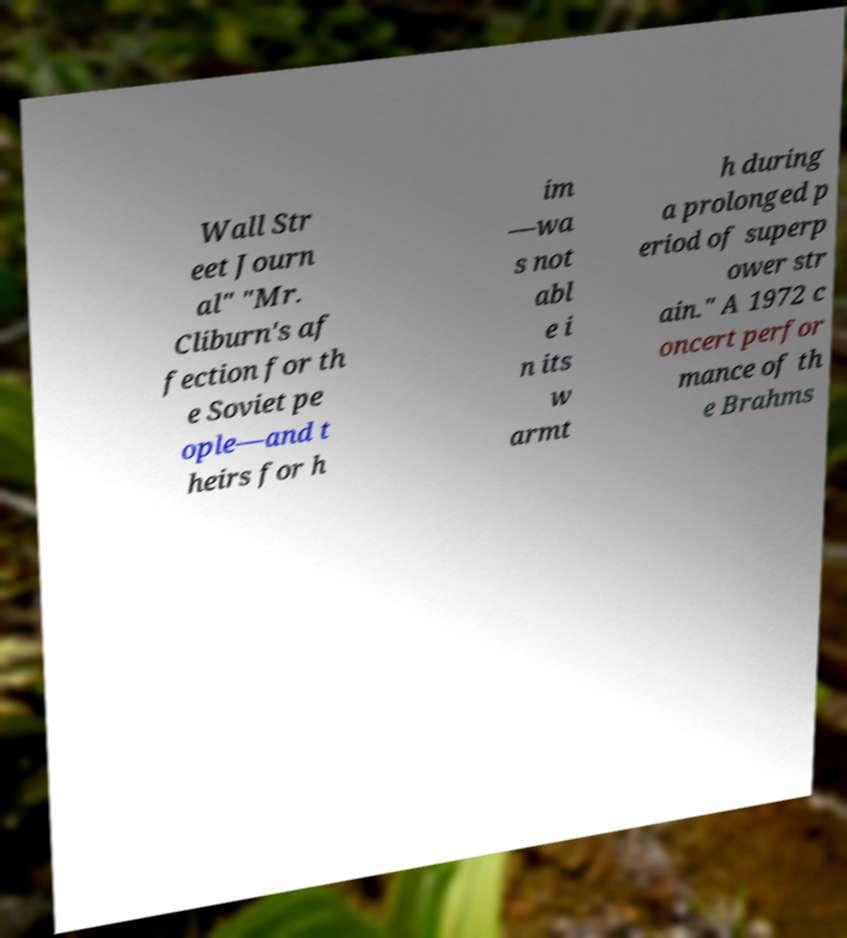What messages or text are displayed in this image? I need them in a readable, typed format. Wall Str eet Journ al" "Mr. Cliburn's af fection for th e Soviet pe ople—and t heirs for h im —wa s not abl e i n its w armt h during a prolonged p eriod of superp ower str ain." A 1972 c oncert perfor mance of th e Brahms 